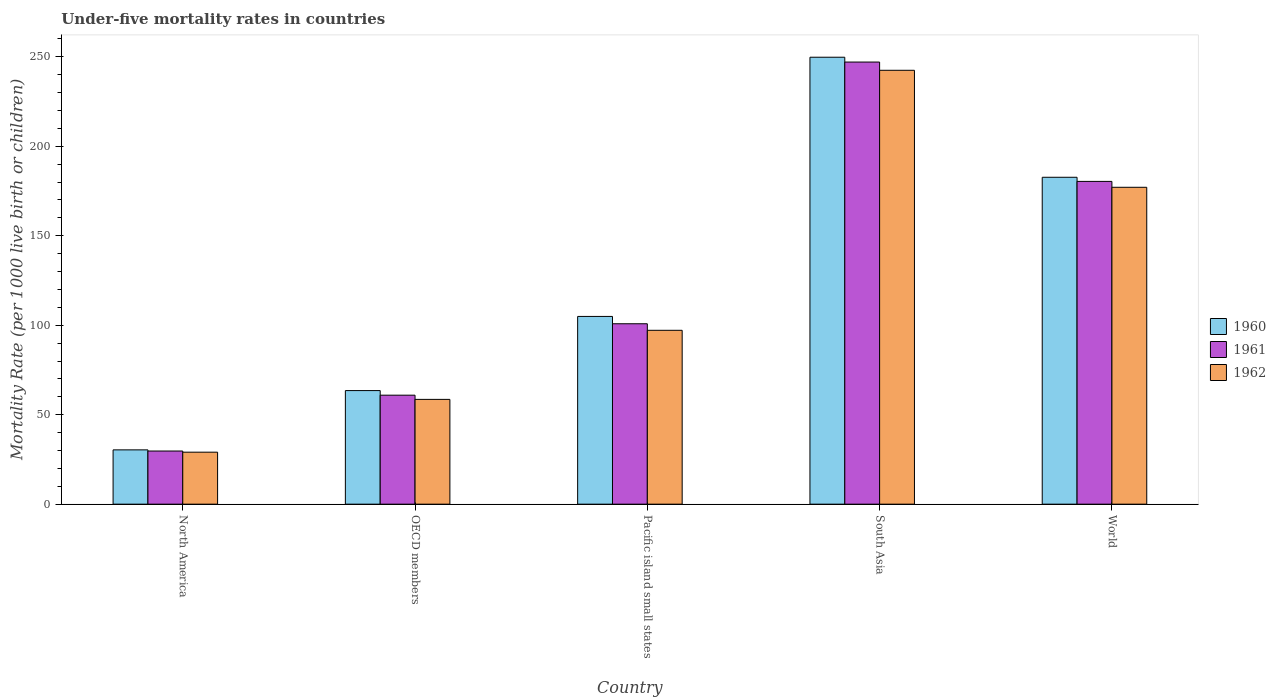How many different coloured bars are there?
Make the answer very short. 3. How many groups of bars are there?
Keep it short and to the point. 5. Are the number of bars per tick equal to the number of legend labels?
Keep it short and to the point. Yes. How many bars are there on the 3rd tick from the left?
Ensure brevity in your answer.  3. What is the under-five mortality rate in 1962 in World?
Make the answer very short. 177.1. Across all countries, what is the maximum under-five mortality rate in 1961?
Provide a succinct answer. 247.1. Across all countries, what is the minimum under-five mortality rate in 1962?
Your answer should be very brief. 29.06. What is the total under-five mortality rate in 1960 in the graph?
Offer a very short reply. 631.25. What is the difference between the under-five mortality rate in 1962 in North America and that in South Asia?
Your answer should be compact. -213.44. What is the difference between the under-five mortality rate in 1961 in North America and the under-five mortality rate in 1960 in Pacific island small states?
Keep it short and to the point. -75.22. What is the average under-five mortality rate in 1962 per country?
Provide a succinct answer. 120.88. What is the difference between the under-five mortality rate of/in 1960 and under-five mortality rate of/in 1962 in South Asia?
Offer a terse response. 7.3. What is the ratio of the under-five mortality rate in 1962 in Pacific island small states to that in South Asia?
Your response must be concise. 0.4. What is the difference between the highest and the second highest under-five mortality rate in 1961?
Provide a succinct answer. -79.57. What is the difference between the highest and the lowest under-five mortality rate in 1961?
Your answer should be very brief. 217.4. In how many countries, is the under-five mortality rate in 1961 greater than the average under-five mortality rate in 1961 taken over all countries?
Keep it short and to the point. 2. Is the sum of the under-five mortality rate in 1960 in OECD members and South Asia greater than the maximum under-five mortality rate in 1962 across all countries?
Give a very brief answer. Yes. What does the 2nd bar from the right in OECD members represents?
Give a very brief answer. 1961. Is it the case that in every country, the sum of the under-five mortality rate in 1961 and under-five mortality rate in 1962 is greater than the under-five mortality rate in 1960?
Ensure brevity in your answer.  Yes. Are all the bars in the graph horizontal?
Your answer should be very brief. No. Does the graph contain grids?
Offer a very short reply. No. How are the legend labels stacked?
Offer a very short reply. Vertical. What is the title of the graph?
Provide a succinct answer. Under-five mortality rates in countries. Does "1971" appear as one of the legend labels in the graph?
Your answer should be very brief. No. What is the label or title of the X-axis?
Offer a very short reply. Country. What is the label or title of the Y-axis?
Your answer should be compact. Mortality Rate (per 1000 live birth or children). What is the Mortality Rate (per 1000 live birth or children) of 1960 in North America?
Your answer should be compact. 30.34. What is the Mortality Rate (per 1000 live birth or children) of 1961 in North America?
Your response must be concise. 29.7. What is the Mortality Rate (per 1000 live birth or children) of 1962 in North America?
Provide a succinct answer. 29.06. What is the Mortality Rate (per 1000 live birth or children) in 1960 in OECD members?
Give a very brief answer. 63.48. What is the Mortality Rate (per 1000 live birth or children) in 1961 in OECD members?
Provide a succinct answer. 60.92. What is the Mortality Rate (per 1000 live birth or children) in 1962 in OECD members?
Your answer should be very brief. 58.57. What is the Mortality Rate (per 1000 live birth or children) in 1960 in Pacific island small states?
Your response must be concise. 104.93. What is the Mortality Rate (per 1000 live birth or children) of 1961 in Pacific island small states?
Your response must be concise. 100.83. What is the Mortality Rate (per 1000 live birth or children) in 1962 in Pacific island small states?
Ensure brevity in your answer.  97.17. What is the Mortality Rate (per 1000 live birth or children) in 1960 in South Asia?
Your response must be concise. 249.8. What is the Mortality Rate (per 1000 live birth or children) in 1961 in South Asia?
Give a very brief answer. 247.1. What is the Mortality Rate (per 1000 live birth or children) in 1962 in South Asia?
Provide a succinct answer. 242.5. What is the Mortality Rate (per 1000 live birth or children) of 1960 in World?
Make the answer very short. 182.7. What is the Mortality Rate (per 1000 live birth or children) in 1961 in World?
Give a very brief answer. 180.4. What is the Mortality Rate (per 1000 live birth or children) in 1962 in World?
Your answer should be very brief. 177.1. Across all countries, what is the maximum Mortality Rate (per 1000 live birth or children) of 1960?
Your answer should be very brief. 249.8. Across all countries, what is the maximum Mortality Rate (per 1000 live birth or children) in 1961?
Provide a succinct answer. 247.1. Across all countries, what is the maximum Mortality Rate (per 1000 live birth or children) of 1962?
Keep it short and to the point. 242.5. Across all countries, what is the minimum Mortality Rate (per 1000 live birth or children) of 1960?
Offer a terse response. 30.34. Across all countries, what is the minimum Mortality Rate (per 1000 live birth or children) of 1961?
Ensure brevity in your answer.  29.7. Across all countries, what is the minimum Mortality Rate (per 1000 live birth or children) in 1962?
Your answer should be compact. 29.06. What is the total Mortality Rate (per 1000 live birth or children) in 1960 in the graph?
Your answer should be very brief. 631.25. What is the total Mortality Rate (per 1000 live birth or children) in 1961 in the graph?
Ensure brevity in your answer.  618.95. What is the total Mortality Rate (per 1000 live birth or children) in 1962 in the graph?
Your answer should be compact. 604.39. What is the difference between the Mortality Rate (per 1000 live birth or children) in 1960 in North America and that in OECD members?
Ensure brevity in your answer.  -33.14. What is the difference between the Mortality Rate (per 1000 live birth or children) in 1961 in North America and that in OECD members?
Provide a succinct answer. -31.21. What is the difference between the Mortality Rate (per 1000 live birth or children) of 1962 in North America and that in OECD members?
Your response must be concise. -29.51. What is the difference between the Mortality Rate (per 1000 live birth or children) in 1960 in North America and that in Pacific island small states?
Ensure brevity in your answer.  -74.59. What is the difference between the Mortality Rate (per 1000 live birth or children) in 1961 in North America and that in Pacific island small states?
Give a very brief answer. -71.12. What is the difference between the Mortality Rate (per 1000 live birth or children) in 1962 in North America and that in Pacific island small states?
Give a very brief answer. -68.12. What is the difference between the Mortality Rate (per 1000 live birth or children) in 1960 in North America and that in South Asia?
Offer a terse response. -219.46. What is the difference between the Mortality Rate (per 1000 live birth or children) of 1961 in North America and that in South Asia?
Provide a short and direct response. -217.4. What is the difference between the Mortality Rate (per 1000 live birth or children) of 1962 in North America and that in South Asia?
Your answer should be very brief. -213.44. What is the difference between the Mortality Rate (per 1000 live birth or children) of 1960 in North America and that in World?
Make the answer very short. -152.36. What is the difference between the Mortality Rate (per 1000 live birth or children) in 1961 in North America and that in World?
Provide a short and direct response. -150.7. What is the difference between the Mortality Rate (per 1000 live birth or children) of 1962 in North America and that in World?
Your answer should be compact. -148.04. What is the difference between the Mortality Rate (per 1000 live birth or children) of 1960 in OECD members and that in Pacific island small states?
Your answer should be very brief. -41.45. What is the difference between the Mortality Rate (per 1000 live birth or children) in 1961 in OECD members and that in Pacific island small states?
Your answer should be compact. -39.91. What is the difference between the Mortality Rate (per 1000 live birth or children) of 1962 in OECD members and that in Pacific island small states?
Make the answer very short. -38.61. What is the difference between the Mortality Rate (per 1000 live birth or children) of 1960 in OECD members and that in South Asia?
Your response must be concise. -186.32. What is the difference between the Mortality Rate (per 1000 live birth or children) in 1961 in OECD members and that in South Asia?
Ensure brevity in your answer.  -186.18. What is the difference between the Mortality Rate (per 1000 live birth or children) of 1962 in OECD members and that in South Asia?
Ensure brevity in your answer.  -183.93. What is the difference between the Mortality Rate (per 1000 live birth or children) in 1960 in OECD members and that in World?
Provide a short and direct response. -119.22. What is the difference between the Mortality Rate (per 1000 live birth or children) of 1961 in OECD members and that in World?
Provide a short and direct response. -119.48. What is the difference between the Mortality Rate (per 1000 live birth or children) in 1962 in OECD members and that in World?
Provide a succinct answer. -118.53. What is the difference between the Mortality Rate (per 1000 live birth or children) of 1960 in Pacific island small states and that in South Asia?
Provide a short and direct response. -144.87. What is the difference between the Mortality Rate (per 1000 live birth or children) in 1961 in Pacific island small states and that in South Asia?
Your answer should be very brief. -146.27. What is the difference between the Mortality Rate (per 1000 live birth or children) of 1962 in Pacific island small states and that in South Asia?
Keep it short and to the point. -145.33. What is the difference between the Mortality Rate (per 1000 live birth or children) of 1960 in Pacific island small states and that in World?
Provide a succinct answer. -77.77. What is the difference between the Mortality Rate (per 1000 live birth or children) of 1961 in Pacific island small states and that in World?
Give a very brief answer. -79.57. What is the difference between the Mortality Rate (per 1000 live birth or children) of 1962 in Pacific island small states and that in World?
Provide a succinct answer. -79.93. What is the difference between the Mortality Rate (per 1000 live birth or children) in 1960 in South Asia and that in World?
Make the answer very short. 67.1. What is the difference between the Mortality Rate (per 1000 live birth or children) of 1961 in South Asia and that in World?
Give a very brief answer. 66.7. What is the difference between the Mortality Rate (per 1000 live birth or children) in 1962 in South Asia and that in World?
Make the answer very short. 65.4. What is the difference between the Mortality Rate (per 1000 live birth or children) of 1960 in North America and the Mortality Rate (per 1000 live birth or children) of 1961 in OECD members?
Provide a short and direct response. -30.57. What is the difference between the Mortality Rate (per 1000 live birth or children) of 1960 in North America and the Mortality Rate (per 1000 live birth or children) of 1962 in OECD members?
Provide a short and direct response. -28.22. What is the difference between the Mortality Rate (per 1000 live birth or children) in 1961 in North America and the Mortality Rate (per 1000 live birth or children) in 1962 in OECD members?
Your response must be concise. -28.86. What is the difference between the Mortality Rate (per 1000 live birth or children) in 1960 in North America and the Mortality Rate (per 1000 live birth or children) in 1961 in Pacific island small states?
Offer a terse response. -70.49. What is the difference between the Mortality Rate (per 1000 live birth or children) in 1960 in North America and the Mortality Rate (per 1000 live birth or children) in 1962 in Pacific island small states?
Your answer should be very brief. -66.83. What is the difference between the Mortality Rate (per 1000 live birth or children) of 1961 in North America and the Mortality Rate (per 1000 live birth or children) of 1962 in Pacific island small states?
Provide a short and direct response. -67.47. What is the difference between the Mortality Rate (per 1000 live birth or children) in 1960 in North America and the Mortality Rate (per 1000 live birth or children) in 1961 in South Asia?
Give a very brief answer. -216.76. What is the difference between the Mortality Rate (per 1000 live birth or children) in 1960 in North America and the Mortality Rate (per 1000 live birth or children) in 1962 in South Asia?
Your answer should be compact. -212.16. What is the difference between the Mortality Rate (per 1000 live birth or children) of 1961 in North America and the Mortality Rate (per 1000 live birth or children) of 1962 in South Asia?
Offer a very short reply. -212.8. What is the difference between the Mortality Rate (per 1000 live birth or children) of 1960 in North America and the Mortality Rate (per 1000 live birth or children) of 1961 in World?
Ensure brevity in your answer.  -150.06. What is the difference between the Mortality Rate (per 1000 live birth or children) of 1960 in North America and the Mortality Rate (per 1000 live birth or children) of 1962 in World?
Your response must be concise. -146.76. What is the difference between the Mortality Rate (per 1000 live birth or children) in 1961 in North America and the Mortality Rate (per 1000 live birth or children) in 1962 in World?
Keep it short and to the point. -147.4. What is the difference between the Mortality Rate (per 1000 live birth or children) of 1960 in OECD members and the Mortality Rate (per 1000 live birth or children) of 1961 in Pacific island small states?
Give a very brief answer. -37.35. What is the difference between the Mortality Rate (per 1000 live birth or children) in 1960 in OECD members and the Mortality Rate (per 1000 live birth or children) in 1962 in Pacific island small states?
Make the answer very short. -33.69. What is the difference between the Mortality Rate (per 1000 live birth or children) of 1961 in OECD members and the Mortality Rate (per 1000 live birth or children) of 1962 in Pacific island small states?
Offer a very short reply. -36.26. What is the difference between the Mortality Rate (per 1000 live birth or children) of 1960 in OECD members and the Mortality Rate (per 1000 live birth or children) of 1961 in South Asia?
Offer a very short reply. -183.62. What is the difference between the Mortality Rate (per 1000 live birth or children) in 1960 in OECD members and the Mortality Rate (per 1000 live birth or children) in 1962 in South Asia?
Keep it short and to the point. -179.02. What is the difference between the Mortality Rate (per 1000 live birth or children) of 1961 in OECD members and the Mortality Rate (per 1000 live birth or children) of 1962 in South Asia?
Your response must be concise. -181.58. What is the difference between the Mortality Rate (per 1000 live birth or children) of 1960 in OECD members and the Mortality Rate (per 1000 live birth or children) of 1961 in World?
Your answer should be very brief. -116.92. What is the difference between the Mortality Rate (per 1000 live birth or children) in 1960 in OECD members and the Mortality Rate (per 1000 live birth or children) in 1962 in World?
Your answer should be compact. -113.62. What is the difference between the Mortality Rate (per 1000 live birth or children) in 1961 in OECD members and the Mortality Rate (per 1000 live birth or children) in 1962 in World?
Give a very brief answer. -116.18. What is the difference between the Mortality Rate (per 1000 live birth or children) in 1960 in Pacific island small states and the Mortality Rate (per 1000 live birth or children) in 1961 in South Asia?
Give a very brief answer. -142.17. What is the difference between the Mortality Rate (per 1000 live birth or children) of 1960 in Pacific island small states and the Mortality Rate (per 1000 live birth or children) of 1962 in South Asia?
Ensure brevity in your answer.  -137.57. What is the difference between the Mortality Rate (per 1000 live birth or children) in 1961 in Pacific island small states and the Mortality Rate (per 1000 live birth or children) in 1962 in South Asia?
Your answer should be compact. -141.67. What is the difference between the Mortality Rate (per 1000 live birth or children) of 1960 in Pacific island small states and the Mortality Rate (per 1000 live birth or children) of 1961 in World?
Provide a short and direct response. -75.47. What is the difference between the Mortality Rate (per 1000 live birth or children) of 1960 in Pacific island small states and the Mortality Rate (per 1000 live birth or children) of 1962 in World?
Your response must be concise. -72.17. What is the difference between the Mortality Rate (per 1000 live birth or children) of 1961 in Pacific island small states and the Mortality Rate (per 1000 live birth or children) of 1962 in World?
Make the answer very short. -76.27. What is the difference between the Mortality Rate (per 1000 live birth or children) of 1960 in South Asia and the Mortality Rate (per 1000 live birth or children) of 1961 in World?
Provide a short and direct response. 69.4. What is the difference between the Mortality Rate (per 1000 live birth or children) of 1960 in South Asia and the Mortality Rate (per 1000 live birth or children) of 1962 in World?
Your answer should be very brief. 72.7. What is the difference between the Mortality Rate (per 1000 live birth or children) of 1961 in South Asia and the Mortality Rate (per 1000 live birth or children) of 1962 in World?
Provide a succinct answer. 70. What is the average Mortality Rate (per 1000 live birth or children) of 1960 per country?
Provide a short and direct response. 126.25. What is the average Mortality Rate (per 1000 live birth or children) in 1961 per country?
Make the answer very short. 123.79. What is the average Mortality Rate (per 1000 live birth or children) of 1962 per country?
Offer a terse response. 120.88. What is the difference between the Mortality Rate (per 1000 live birth or children) of 1960 and Mortality Rate (per 1000 live birth or children) of 1961 in North America?
Your answer should be very brief. 0.64. What is the difference between the Mortality Rate (per 1000 live birth or children) in 1960 and Mortality Rate (per 1000 live birth or children) in 1962 in North America?
Give a very brief answer. 1.29. What is the difference between the Mortality Rate (per 1000 live birth or children) in 1961 and Mortality Rate (per 1000 live birth or children) in 1962 in North America?
Give a very brief answer. 0.65. What is the difference between the Mortality Rate (per 1000 live birth or children) of 1960 and Mortality Rate (per 1000 live birth or children) of 1961 in OECD members?
Keep it short and to the point. 2.57. What is the difference between the Mortality Rate (per 1000 live birth or children) of 1960 and Mortality Rate (per 1000 live birth or children) of 1962 in OECD members?
Offer a terse response. 4.92. What is the difference between the Mortality Rate (per 1000 live birth or children) of 1961 and Mortality Rate (per 1000 live birth or children) of 1962 in OECD members?
Ensure brevity in your answer.  2.35. What is the difference between the Mortality Rate (per 1000 live birth or children) of 1960 and Mortality Rate (per 1000 live birth or children) of 1961 in Pacific island small states?
Provide a short and direct response. 4.1. What is the difference between the Mortality Rate (per 1000 live birth or children) of 1960 and Mortality Rate (per 1000 live birth or children) of 1962 in Pacific island small states?
Your response must be concise. 7.76. What is the difference between the Mortality Rate (per 1000 live birth or children) of 1961 and Mortality Rate (per 1000 live birth or children) of 1962 in Pacific island small states?
Provide a short and direct response. 3.66. What is the difference between the Mortality Rate (per 1000 live birth or children) in 1960 and Mortality Rate (per 1000 live birth or children) in 1962 in South Asia?
Offer a terse response. 7.3. What is the difference between the Mortality Rate (per 1000 live birth or children) of 1961 and Mortality Rate (per 1000 live birth or children) of 1962 in South Asia?
Keep it short and to the point. 4.6. What is the difference between the Mortality Rate (per 1000 live birth or children) of 1960 and Mortality Rate (per 1000 live birth or children) of 1961 in World?
Your answer should be very brief. 2.3. What is the difference between the Mortality Rate (per 1000 live birth or children) in 1961 and Mortality Rate (per 1000 live birth or children) in 1962 in World?
Your response must be concise. 3.3. What is the ratio of the Mortality Rate (per 1000 live birth or children) of 1960 in North America to that in OECD members?
Provide a short and direct response. 0.48. What is the ratio of the Mortality Rate (per 1000 live birth or children) in 1961 in North America to that in OECD members?
Your answer should be compact. 0.49. What is the ratio of the Mortality Rate (per 1000 live birth or children) of 1962 in North America to that in OECD members?
Your response must be concise. 0.5. What is the ratio of the Mortality Rate (per 1000 live birth or children) of 1960 in North America to that in Pacific island small states?
Your answer should be compact. 0.29. What is the ratio of the Mortality Rate (per 1000 live birth or children) in 1961 in North America to that in Pacific island small states?
Keep it short and to the point. 0.29. What is the ratio of the Mortality Rate (per 1000 live birth or children) of 1962 in North America to that in Pacific island small states?
Your response must be concise. 0.3. What is the ratio of the Mortality Rate (per 1000 live birth or children) in 1960 in North America to that in South Asia?
Your response must be concise. 0.12. What is the ratio of the Mortality Rate (per 1000 live birth or children) in 1961 in North America to that in South Asia?
Keep it short and to the point. 0.12. What is the ratio of the Mortality Rate (per 1000 live birth or children) in 1962 in North America to that in South Asia?
Make the answer very short. 0.12. What is the ratio of the Mortality Rate (per 1000 live birth or children) of 1960 in North America to that in World?
Give a very brief answer. 0.17. What is the ratio of the Mortality Rate (per 1000 live birth or children) in 1961 in North America to that in World?
Your answer should be very brief. 0.16. What is the ratio of the Mortality Rate (per 1000 live birth or children) of 1962 in North America to that in World?
Give a very brief answer. 0.16. What is the ratio of the Mortality Rate (per 1000 live birth or children) of 1960 in OECD members to that in Pacific island small states?
Provide a short and direct response. 0.6. What is the ratio of the Mortality Rate (per 1000 live birth or children) in 1961 in OECD members to that in Pacific island small states?
Your answer should be compact. 0.6. What is the ratio of the Mortality Rate (per 1000 live birth or children) in 1962 in OECD members to that in Pacific island small states?
Offer a terse response. 0.6. What is the ratio of the Mortality Rate (per 1000 live birth or children) of 1960 in OECD members to that in South Asia?
Your answer should be very brief. 0.25. What is the ratio of the Mortality Rate (per 1000 live birth or children) in 1961 in OECD members to that in South Asia?
Make the answer very short. 0.25. What is the ratio of the Mortality Rate (per 1000 live birth or children) of 1962 in OECD members to that in South Asia?
Ensure brevity in your answer.  0.24. What is the ratio of the Mortality Rate (per 1000 live birth or children) of 1960 in OECD members to that in World?
Your answer should be compact. 0.35. What is the ratio of the Mortality Rate (per 1000 live birth or children) in 1961 in OECD members to that in World?
Provide a short and direct response. 0.34. What is the ratio of the Mortality Rate (per 1000 live birth or children) in 1962 in OECD members to that in World?
Keep it short and to the point. 0.33. What is the ratio of the Mortality Rate (per 1000 live birth or children) of 1960 in Pacific island small states to that in South Asia?
Ensure brevity in your answer.  0.42. What is the ratio of the Mortality Rate (per 1000 live birth or children) of 1961 in Pacific island small states to that in South Asia?
Your response must be concise. 0.41. What is the ratio of the Mortality Rate (per 1000 live birth or children) of 1962 in Pacific island small states to that in South Asia?
Make the answer very short. 0.4. What is the ratio of the Mortality Rate (per 1000 live birth or children) in 1960 in Pacific island small states to that in World?
Give a very brief answer. 0.57. What is the ratio of the Mortality Rate (per 1000 live birth or children) of 1961 in Pacific island small states to that in World?
Provide a succinct answer. 0.56. What is the ratio of the Mortality Rate (per 1000 live birth or children) in 1962 in Pacific island small states to that in World?
Make the answer very short. 0.55. What is the ratio of the Mortality Rate (per 1000 live birth or children) in 1960 in South Asia to that in World?
Keep it short and to the point. 1.37. What is the ratio of the Mortality Rate (per 1000 live birth or children) of 1961 in South Asia to that in World?
Your response must be concise. 1.37. What is the ratio of the Mortality Rate (per 1000 live birth or children) in 1962 in South Asia to that in World?
Provide a short and direct response. 1.37. What is the difference between the highest and the second highest Mortality Rate (per 1000 live birth or children) in 1960?
Keep it short and to the point. 67.1. What is the difference between the highest and the second highest Mortality Rate (per 1000 live birth or children) of 1961?
Your response must be concise. 66.7. What is the difference between the highest and the second highest Mortality Rate (per 1000 live birth or children) in 1962?
Make the answer very short. 65.4. What is the difference between the highest and the lowest Mortality Rate (per 1000 live birth or children) of 1960?
Your response must be concise. 219.46. What is the difference between the highest and the lowest Mortality Rate (per 1000 live birth or children) in 1961?
Provide a succinct answer. 217.4. What is the difference between the highest and the lowest Mortality Rate (per 1000 live birth or children) of 1962?
Your answer should be compact. 213.44. 